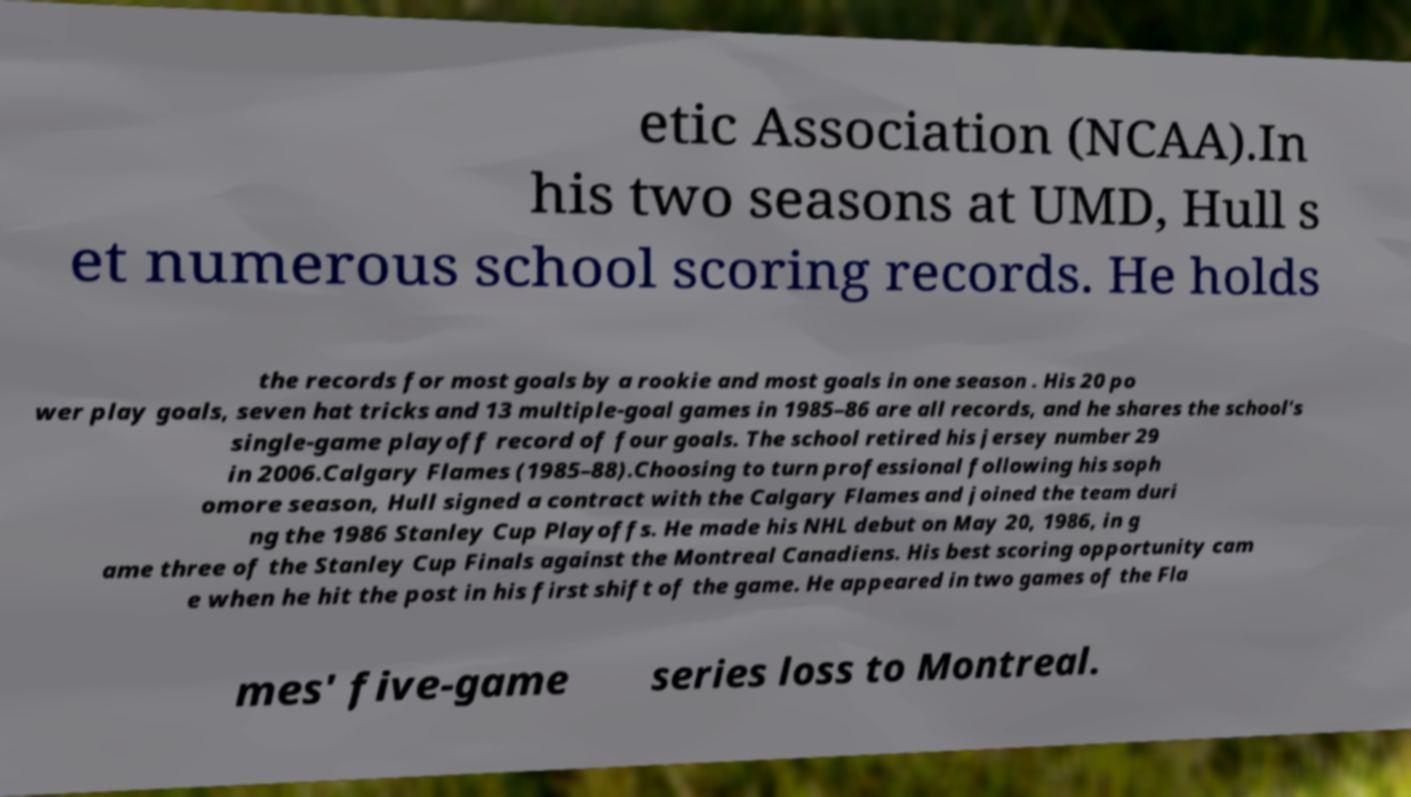Could you extract and type out the text from this image? etic Association (NCAA).In his two seasons at UMD, Hull s et numerous school scoring records. He holds the records for most goals by a rookie and most goals in one season . His 20 po wer play goals, seven hat tricks and 13 multiple-goal games in 1985–86 are all records, and he shares the school's single-game playoff record of four goals. The school retired his jersey number 29 in 2006.Calgary Flames (1985–88).Choosing to turn professional following his soph omore season, Hull signed a contract with the Calgary Flames and joined the team duri ng the 1986 Stanley Cup Playoffs. He made his NHL debut on May 20, 1986, in g ame three of the Stanley Cup Finals against the Montreal Canadiens. His best scoring opportunity cam e when he hit the post in his first shift of the game. He appeared in two games of the Fla mes' five-game series loss to Montreal. 